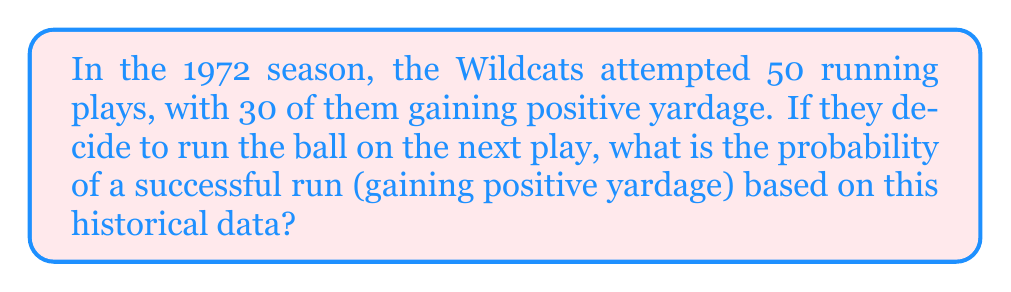Could you help me with this problem? Let's approach this step-by-step using basic probability concepts:

1) First, we need to identify the total number of attempts and the number of successful attempts:
   - Total running plays: 50
   - Successful running plays (gaining positive yardage): 30

2) The probability of an event is calculated by dividing the number of favorable outcomes by the total number of possible outcomes:

   $$P(\text{success}) = \frac{\text{number of successful outcomes}}{\text{total number of outcomes}}$$

3) In this case:
   $$P(\text{successful run}) = \frac{\text{number of successful runs}}{\text{total number of runs}}$$

4) Substituting the values:
   $$P(\text{successful run}) = \frac{30}{50}$$

5) Simplifying the fraction:
   $$P(\text{successful run}) = \frac{3}{5} = 0.6$$

6) To express this as a percentage, multiply by 100:
   $$0.6 \times 100 = 60\%$$

Therefore, based on the historical data from the 1972 season, the probability of a successful running play (gaining positive yardage) is 0.6 or 60%.
Answer: 0.6 or 60% 